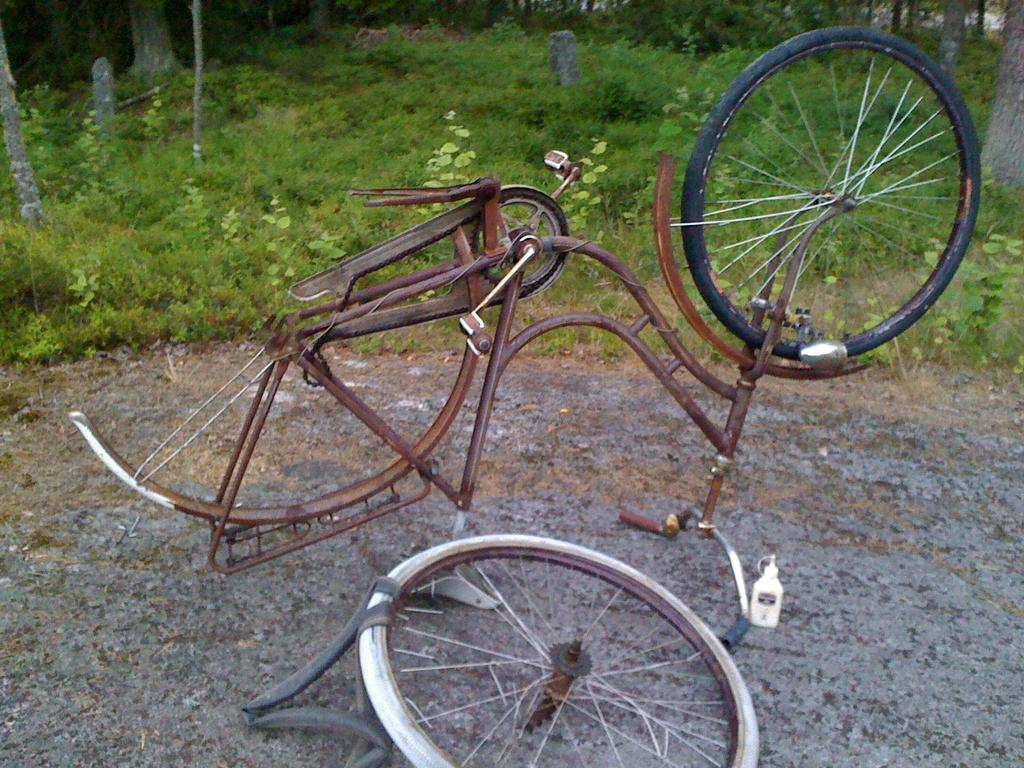What type of objects are present in the image? There are bicycle parts in the image. What colors can be seen in the bicycle parts? The bicycle parts are in brown and black colors. What type of natural environment is visible in the image? There is green grass visible in the image. Are there any other natural elements present in the image? Yes, there are trees in the image. What type of insect can be seen coughing in the image? There are no insects or coughing sounds present in the image. 